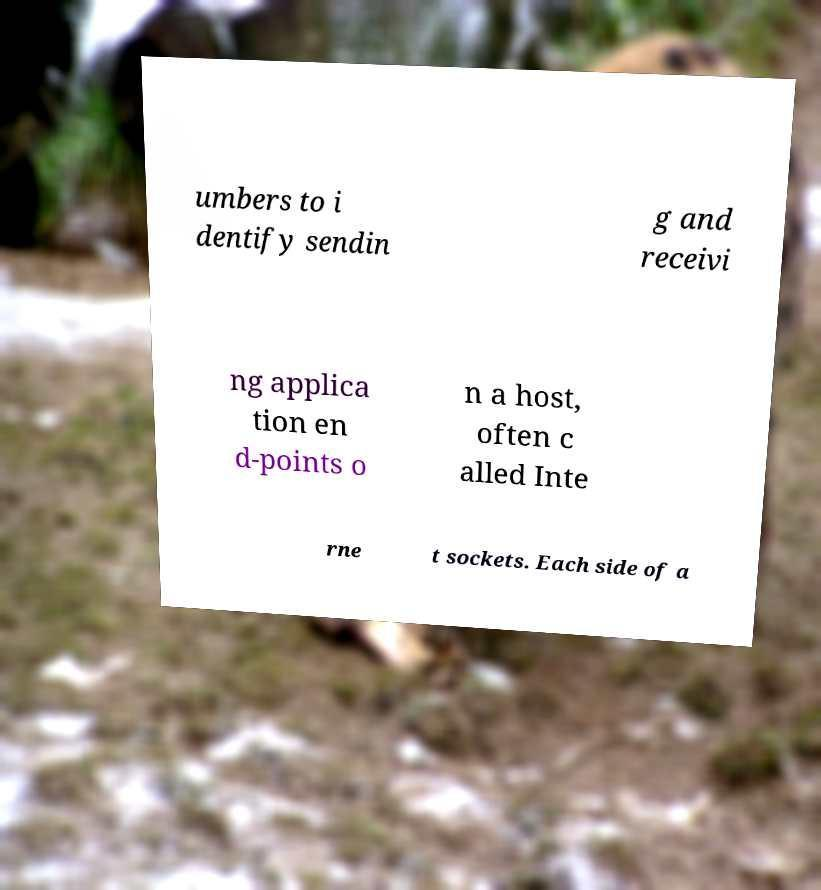Could you extract and type out the text from this image? umbers to i dentify sendin g and receivi ng applica tion en d-points o n a host, often c alled Inte rne t sockets. Each side of a 